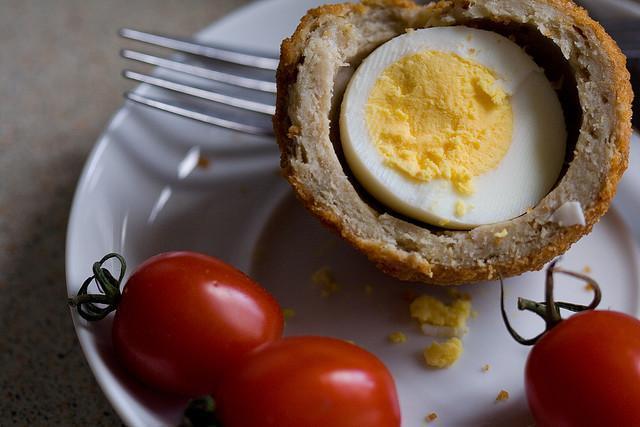Is the caption "The sandwich is at the edge of the dining table." a true representation of the image?
Answer yes or no. No. 